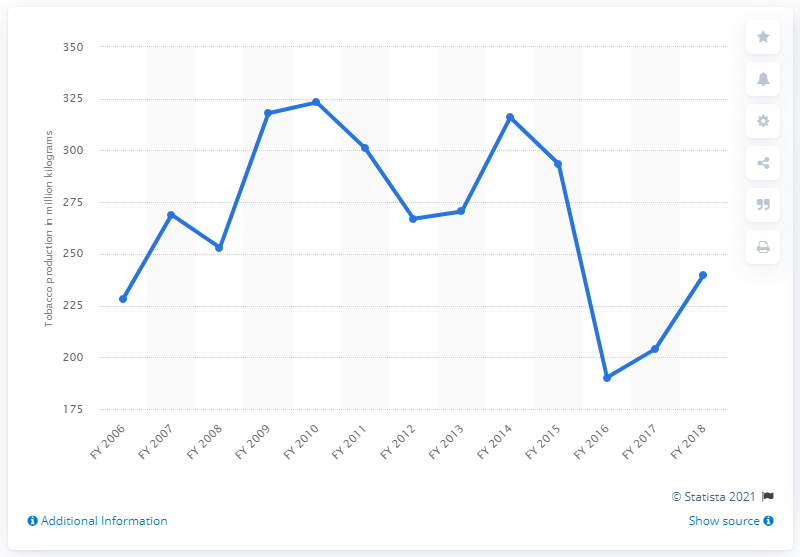Identify some key points in this picture. In the fiscal year 2018, a total of 239.94 metric tons of flue-cured tobacco was produced in India. 